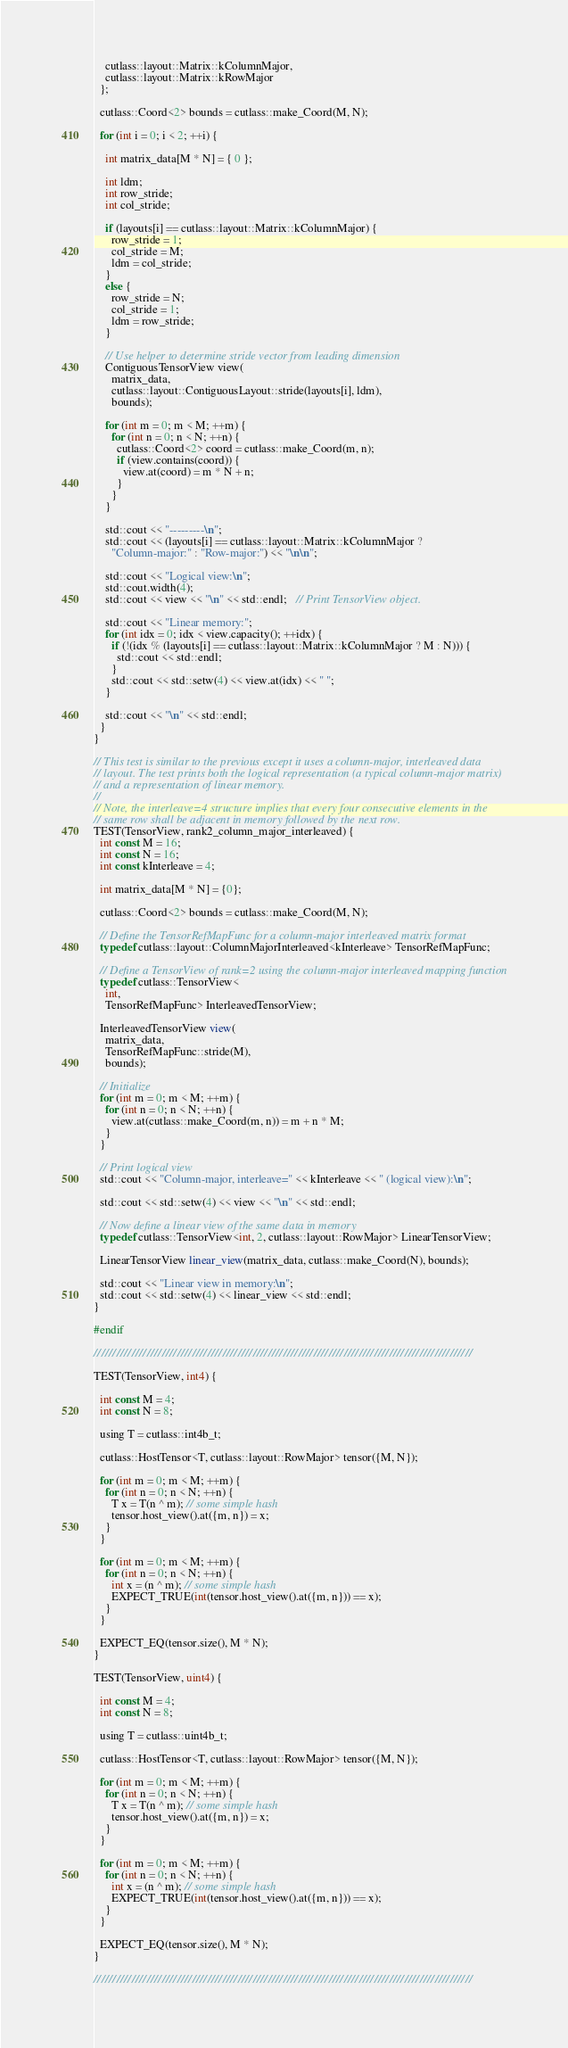<code> <loc_0><loc_0><loc_500><loc_500><_Cuda_>    cutlass::layout::Matrix::kColumnMajor,
    cutlass::layout::Matrix::kRowMajor
  };

  cutlass::Coord<2> bounds = cutlass::make_Coord(M, N);

  for (int i = 0; i < 2; ++i) {

    int matrix_data[M * N] = { 0 };

    int ldm;
    int row_stride;
    int col_stride;

    if (layouts[i] == cutlass::layout::Matrix::kColumnMajor) {
      row_stride = 1;
      col_stride = M;
      ldm = col_stride;
    }
    else {
      row_stride = N;
      col_stride = 1;
      ldm = row_stride;
    }

    // Use helper to determine stride vector from leading dimension
    ContiguousTensorView view(
      matrix_data,
      cutlass::layout::ContiguousLayout::stride(layouts[i], ldm),
      bounds);

    for (int m = 0; m < M; ++m) {
      for (int n = 0; n < N; ++n) {
        cutlass::Coord<2> coord = cutlass::make_Coord(m, n);
        if (view.contains(coord)) {
          view.at(coord) = m * N + n;
        }
      }
    }

    std::cout << "---------\n";
    std::cout << (layouts[i] == cutlass::layout::Matrix::kColumnMajor ?
      "Column-major:" : "Row-major:") << "\n\n";

    std::cout << "Logical view:\n";
    std::cout.width(4);
    std::cout << view << "\n" << std::endl;   // Print TensorView object.

    std::cout << "Linear memory:";
    for (int idx = 0; idx < view.capacity(); ++idx) {
      if (!(idx % (layouts[i] == cutlass::layout::Matrix::kColumnMajor ? M : N))) {
        std::cout << std::endl;
      }
      std::cout << std::setw(4) << view.at(idx) << " ";
    }

    std::cout << "\n" << std::endl;
  }
}

// This test is similar to the previous except it uses a column-major, interleaved data
// layout. The test prints both the logical representation (a typical column-major matrix)
// and a representation of linear memory.
//
// Note, the interleave=4 structure implies that every four consecutive elements in the
// same row shall be adjacent in memory followed by the next row.
TEST(TensorView, rank2_column_major_interleaved) {
  int const M = 16;
  int const N = 16;
  int const kInterleave = 4;

  int matrix_data[M * N] = {0};

  cutlass::Coord<2> bounds = cutlass::make_Coord(M, N);

  // Define the TensorRefMapFunc for a column-major interleaved matrix format
  typedef cutlass::layout::ColumnMajorInterleaved<kInterleave> TensorRefMapFunc;

  // Define a TensorView of rank=2 using the column-major interleaved mapping function
  typedef cutlass::TensorView<
    int,
    TensorRefMapFunc> InterleavedTensorView;

  InterleavedTensorView view(
    matrix_data,
    TensorRefMapFunc::stride(M),
    bounds);

  // Initialize
  for (int m = 0; m < M; ++m) {
    for (int n = 0; n < N; ++n) {
      view.at(cutlass::make_Coord(m, n)) = m + n * M;
    }
  }

  // Print logical view
  std::cout << "Column-major, interleave=" << kInterleave << " (logical view):\n";

  std::cout << std::setw(4) << view << "\n" << std::endl;

  // Now define a linear view of the same data in memory
  typedef cutlass::TensorView<int, 2, cutlass::layout::RowMajor> LinearTensorView;

  LinearTensorView linear_view(matrix_data, cutlass::make_Coord(N), bounds);

  std::cout << "Linear view in memory:\n";
  std::cout << std::setw(4) << linear_view << std::endl;
}

#endif

////////////////////////////////////////////////////////////////////////////////////////////////////

TEST(TensorView, int4) {

  int const M = 4;
  int const N = 8;

  using T = cutlass::int4b_t;

  cutlass::HostTensor<T, cutlass::layout::RowMajor> tensor({M, N});

  for (int m = 0; m < M; ++m) {
    for (int n = 0; n < N; ++n) {
      T x = T(n ^ m); // some simple hash
      tensor.host_view().at({m, n}) = x;
    }
  }

  for (int m = 0; m < M; ++m) {
    for (int n = 0; n < N; ++n) {
      int x = (n ^ m); // some simple hash
      EXPECT_TRUE(int(tensor.host_view().at({m, n})) == x);
    }
  }

  EXPECT_EQ(tensor.size(), M * N);
}

TEST(TensorView, uint4) {

  int const M = 4;
  int const N = 8;

  using T = cutlass::uint4b_t;

  cutlass::HostTensor<T, cutlass::layout::RowMajor> tensor({M, N});

  for (int m = 0; m < M; ++m) {
    for (int n = 0; n < N; ++n) {
      T x = T(n ^ m); // some simple hash
      tensor.host_view().at({m, n}) = x;
    }
  }

  for (int m = 0; m < M; ++m) {
    for (int n = 0; n < N; ++n) {
      int x = (n ^ m); // some simple hash
      EXPECT_TRUE(int(tensor.host_view().at({m, n})) == x);
    }
  }

  EXPECT_EQ(tensor.size(), M * N);
}

////////////////////////////////////////////////////////////////////////////////////////////////////
</code> 